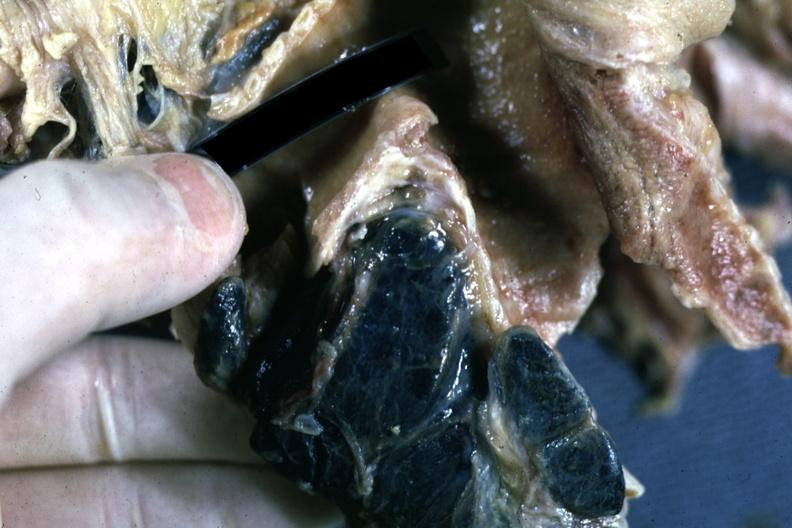how is fixed tissue sectioned carinal nodes shown close-up nodes are filled with pigment?
Answer the question using a single word or phrase. Black 